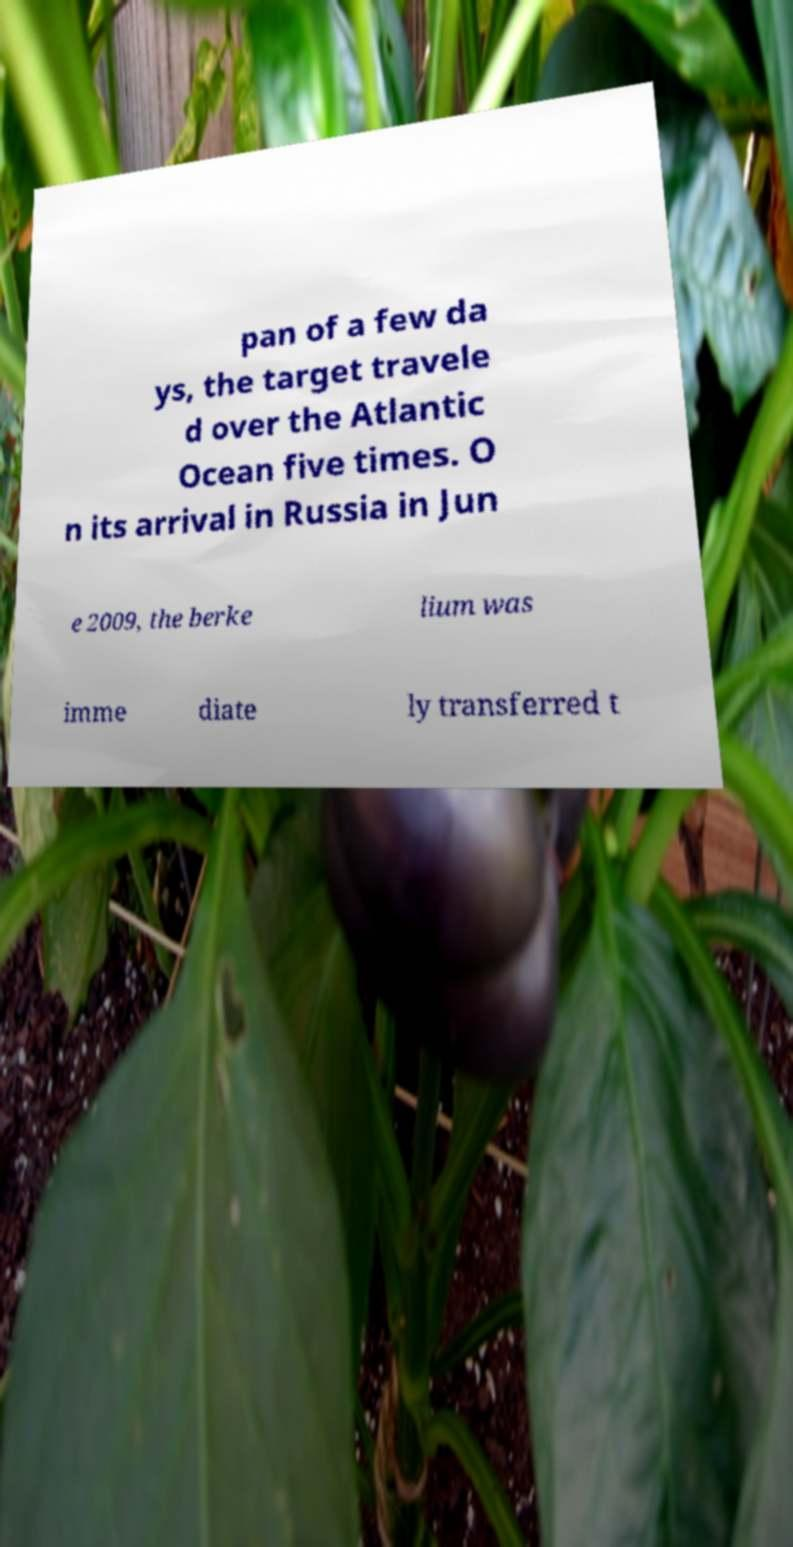I need the written content from this picture converted into text. Can you do that? pan of a few da ys, the target travele d over the Atlantic Ocean five times. O n its arrival in Russia in Jun e 2009, the berke lium was imme diate ly transferred t 